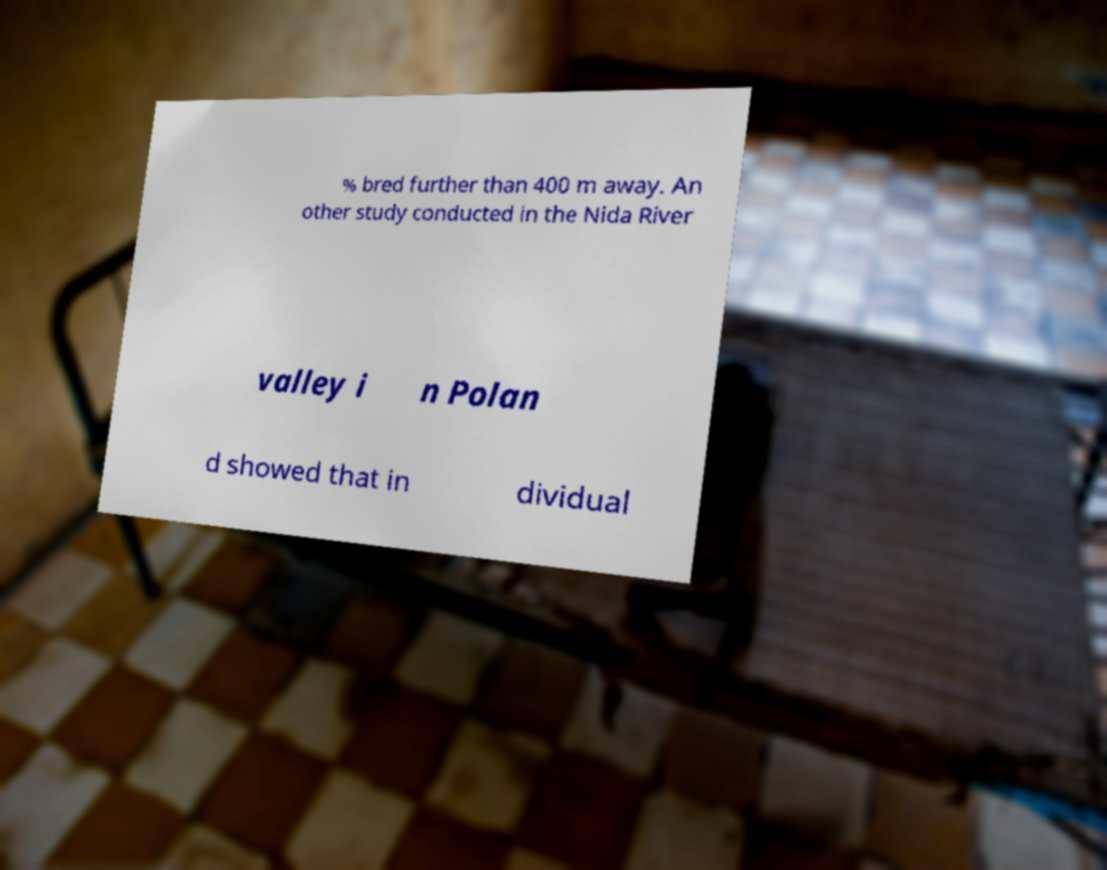I need the written content from this picture converted into text. Can you do that? % bred further than 400 m away. An other study conducted in the Nida River valley i n Polan d showed that in dividual 